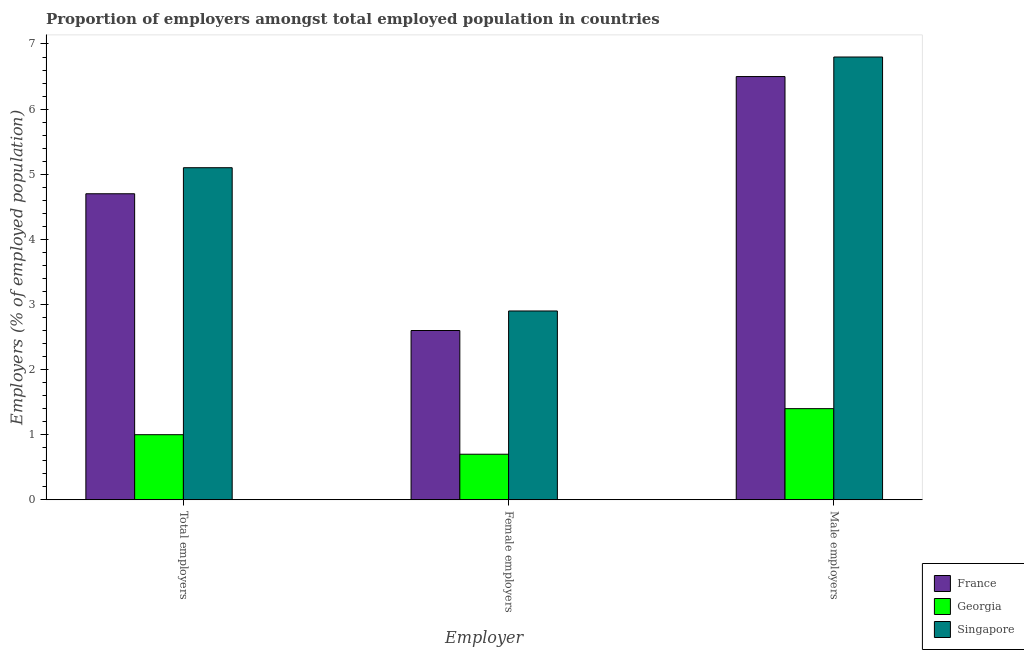How many different coloured bars are there?
Offer a terse response. 3. How many groups of bars are there?
Give a very brief answer. 3. Are the number of bars per tick equal to the number of legend labels?
Your answer should be very brief. Yes. How many bars are there on the 3rd tick from the left?
Your answer should be very brief. 3. What is the label of the 2nd group of bars from the left?
Give a very brief answer. Female employers. What is the percentage of total employers in France?
Keep it short and to the point. 4.7. Across all countries, what is the maximum percentage of total employers?
Offer a very short reply. 5.1. Across all countries, what is the minimum percentage of total employers?
Ensure brevity in your answer.  1. In which country was the percentage of male employers maximum?
Provide a succinct answer. Singapore. In which country was the percentage of total employers minimum?
Your answer should be compact. Georgia. What is the total percentage of male employers in the graph?
Ensure brevity in your answer.  14.7. What is the difference between the percentage of female employers in Georgia and that in Singapore?
Give a very brief answer. -2.2. What is the difference between the percentage of total employers in Singapore and the percentage of male employers in France?
Offer a terse response. -1.4. What is the average percentage of total employers per country?
Keep it short and to the point. 3.6. What is the difference between the percentage of total employers and percentage of female employers in Georgia?
Offer a very short reply. 0.3. What is the ratio of the percentage of total employers in France to that in Singapore?
Keep it short and to the point. 0.92. Is the percentage of total employers in Georgia less than that in Singapore?
Keep it short and to the point. Yes. Is the difference between the percentage of male employers in Georgia and France greater than the difference between the percentage of female employers in Georgia and France?
Offer a terse response. No. What is the difference between the highest and the second highest percentage of female employers?
Your response must be concise. 0.3. What is the difference between the highest and the lowest percentage of female employers?
Your answer should be compact. 2.2. In how many countries, is the percentage of male employers greater than the average percentage of male employers taken over all countries?
Your answer should be compact. 2. What does the 2nd bar from the right in Male employers represents?
Your answer should be compact. Georgia. Is it the case that in every country, the sum of the percentage of total employers and percentage of female employers is greater than the percentage of male employers?
Offer a terse response. Yes. How many countries are there in the graph?
Your response must be concise. 3. What is the difference between two consecutive major ticks on the Y-axis?
Give a very brief answer. 1. Where does the legend appear in the graph?
Make the answer very short. Bottom right. How are the legend labels stacked?
Ensure brevity in your answer.  Vertical. What is the title of the graph?
Ensure brevity in your answer.  Proportion of employers amongst total employed population in countries. What is the label or title of the X-axis?
Keep it short and to the point. Employer. What is the label or title of the Y-axis?
Give a very brief answer. Employers (% of employed population). What is the Employers (% of employed population) in France in Total employers?
Offer a terse response. 4.7. What is the Employers (% of employed population) of Singapore in Total employers?
Your answer should be compact. 5.1. What is the Employers (% of employed population) in France in Female employers?
Your response must be concise. 2.6. What is the Employers (% of employed population) of Georgia in Female employers?
Give a very brief answer. 0.7. What is the Employers (% of employed population) of Singapore in Female employers?
Your answer should be very brief. 2.9. What is the Employers (% of employed population) of France in Male employers?
Make the answer very short. 6.5. What is the Employers (% of employed population) in Georgia in Male employers?
Offer a very short reply. 1.4. What is the Employers (% of employed population) in Singapore in Male employers?
Provide a succinct answer. 6.8. Across all Employer, what is the maximum Employers (% of employed population) in France?
Offer a very short reply. 6.5. Across all Employer, what is the maximum Employers (% of employed population) of Georgia?
Ensure brevity in your answer.  1.4. Across all Employer, what is the maximum Employers (% of employed population) in Singapore?
Offer a terse response. 6.8. Across all Employer, what is the minimum Employers (% of employed population) in France?
Make the answer very short. 2.6. Across all Employer, what is the minimum Employers (% of employed population) of Georgia?
Offer a terse response. 0.7. Across all Employer, what is the minimum Employers (% of employed population) in Singapore?
Your response must be concise. 2.9. What is the total Employers (% of employed population) of Singapore in the graph?
Offer a very short reply. 14.8. What is the difference between the Employers (% of employed population) of Georgia in Total employers and that in Female employers?
Your answer should be compact. 0.3. What is the difference between the Employers (% of employed population) in Singapore in Total employers and that in Female employers?
Offer a very short reply. 2.2. What is the difference between the Employers (% of employed population) in Singapore in Total employers and that in Male employers?
Provide a succinct answer. -1.7. What is the difference between the Employers (% of employed population) in Georgia in Female employers and that in Male employers?
Ensure brevity in your answer.  -0.7. What is the difference between the Employers (% of employed population) in Singapore in Female employers and that in Male employers?
Make the answer very short. -3.9. What is the difference between the Employers (% of employed population) of France in Total employers and the Employers (% of employed population) of Georgia in Female employers?
Give a very brief answer. 4. What is the difference between the Employers (% of employed population) of Georgia in Total employers and the Employers (% of employed population) of Singapore in Female employers?
Provide a succinct answer. -1.9. What is the difference between the Employers (% of employed population) in Georgia in Total employers and the Employers (% of employed population) in Singapore in Male employers?
Give a very brief answer. -5.8. What is the difference between the Employers (% of employed population) of France in Female employers and the Employers (% of employed population) of Georgia in Male employers?
Offer a terse response. 1.2. What is the average Employers (% of employed population) of Georgia per Employer?
Ensure brevity in your answer.  1.03. What is the average Employers (% of employed population) in Singapore per Employer?
Your response must be concise. 4.93. What is the difference between the Employers (% of employed population) of France and Employers (% of employed population) of Singapore in Total employers?
Offer a very short reply. -0.4. What is the difference between the Employers (% of employed population) in Georgia and Employers (% of employed population) in Singapore in Total employers?
Keep it short and to the point. -4.1. What is the difference between the Employers (% of employed population) of France and Employers (% of employed population) of Georgia in Female employers?
Your answer should be very brief. 1.9. What is the difference between the Employers (% of employed population) in France and Employers (% of employed population) in Singapore in Male employers?
Ensure brevity in your answer.  -0.3. What is the ratio of the Employers (% of employed population) of France in Total employers to that in Female employers?
Provide a short and direct response. 1.81. What is the ratio of the Employers (% of employed population) of Georgia in Total employers to that in Female employers?
Give a very brief answer. 1.43. What is the ratio of the Employers (% of employed population) in Singapore in Total employers to that in Female employers?
Your answer should be very brief. 1.76. What is the ratio of the Employers (% of employed population) in France in Total employers to that in Male employers?
Provide a short and direct response. 0.72. What is the ratio of the Employers (% of employed population) of Singapore in Total employers to that in Male employers?
Provide a short and direct response. 0.75. What is the ratio of the Employers (% of employed population) in Georgia in Female employers to that in Male employers?
Your answer should be compact. 0.5. What is the ratio of the Employers (% of employed population) in Singapore in Female employers to that in Male employers?
Provide a short and direct response. 0.43. What is the difference between the highest and the second highest Employers (% of employed population) of Georgia?
Keep it short and to the point. 0.4. What is the difference between the highest and the second highest Employers (% of employed population) in Singapore?
Offer a terse response. 1.7. What is the difference between the highest and the lowest Employers (% of employed population) in France?
Provide a succinct answer. 3.9. 